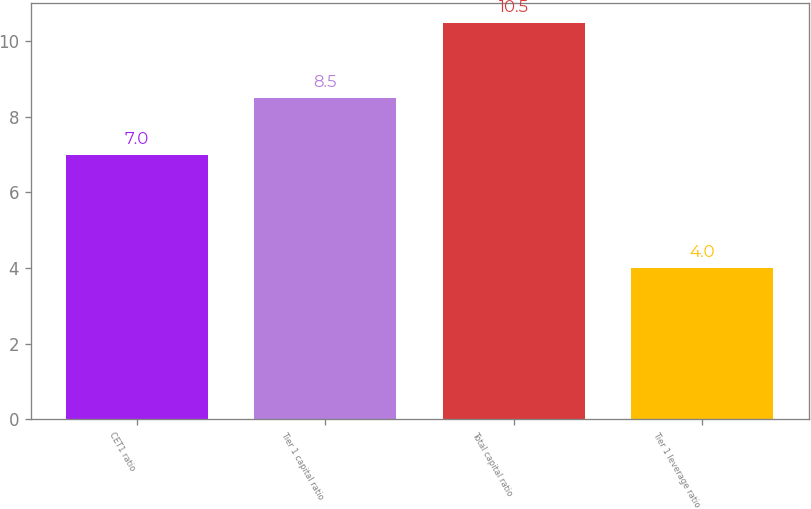<chart> <loc_0><loc_0><loc_500><loc_500><bar_chart><fcel>CET1 ratio<fcel>Tier 1 capital ratio<fcel>Total capital ratio<fcel>Tier 1 leverage ratio<nl><fcel>7<fcel>8.5<fcel>10.5<fcel>4<nl></chart> 